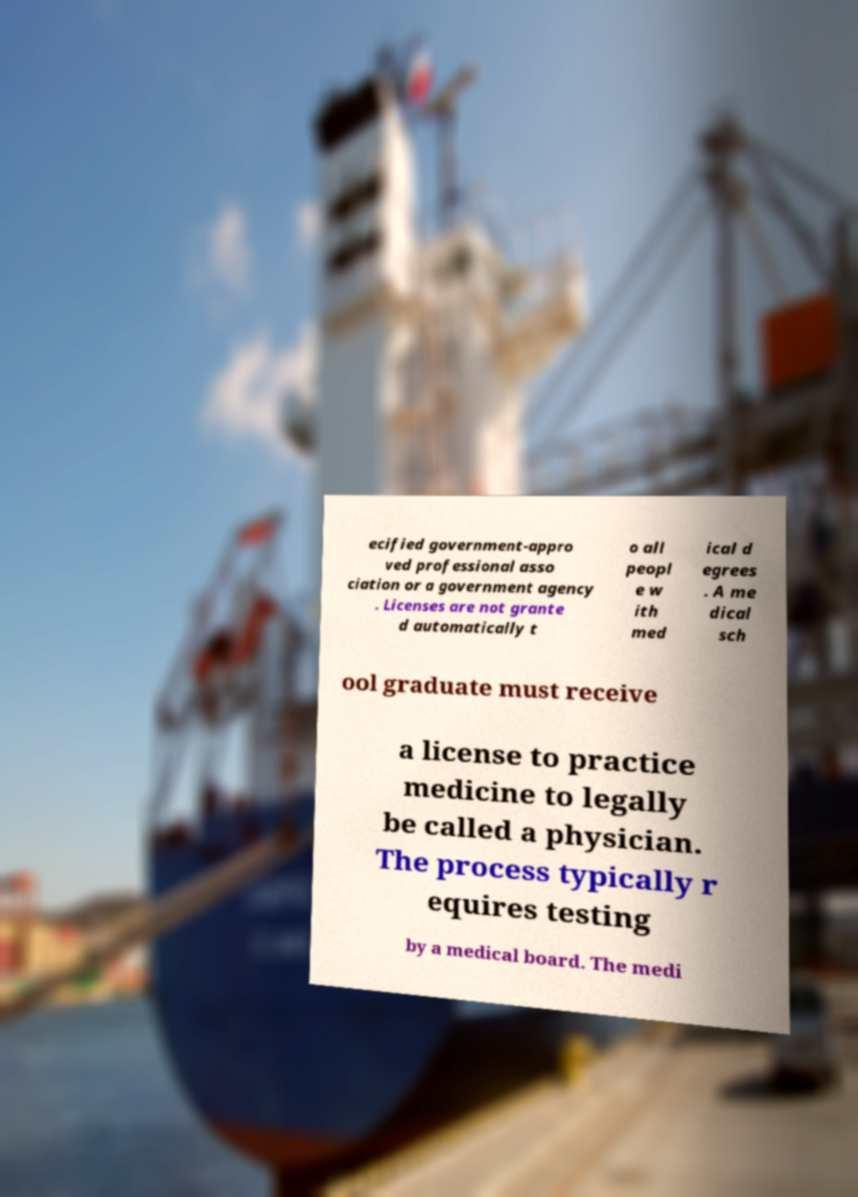Please read and relay the text visible in this image. What does it say? ecified government-appro ved professional asso ciation or a government agency . Licenses are not grante d automatically t o all peopl e w ith med ical d egrees . A me dical sch ool graduate must receive a license to practice medicine to legally be called a physician. The process typically r equires testing by a medical board. The medi 